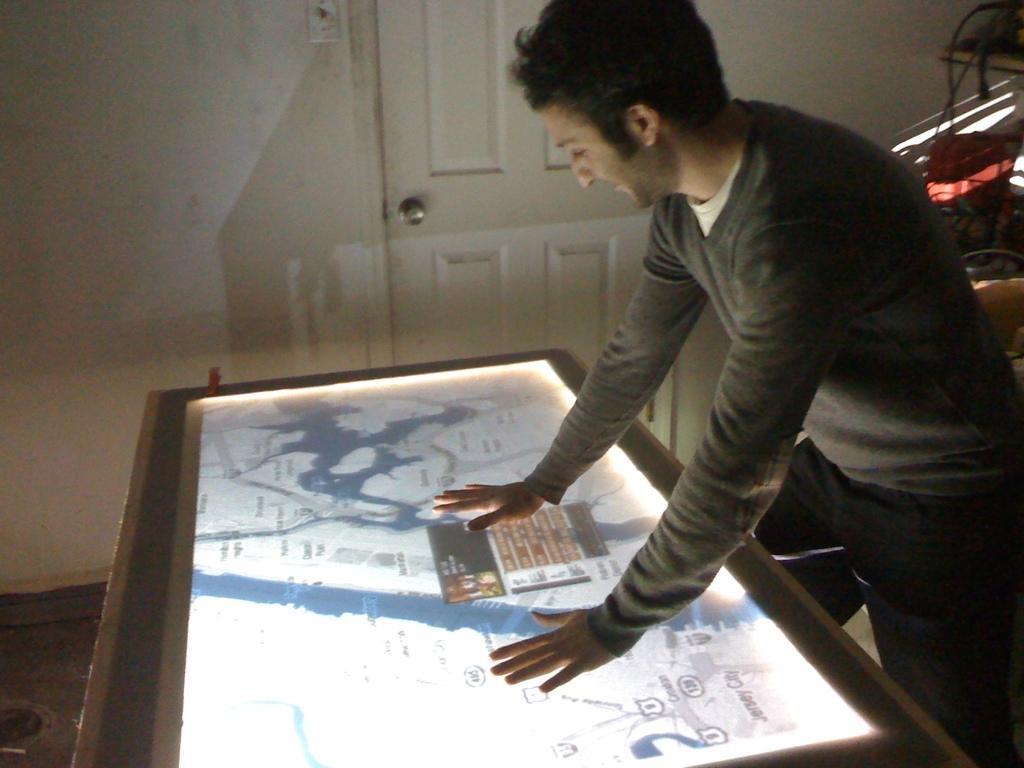Describe this image in one or two sentences. In this picture I can see a person standing in front of the screen, behind there is a door to the wall. 